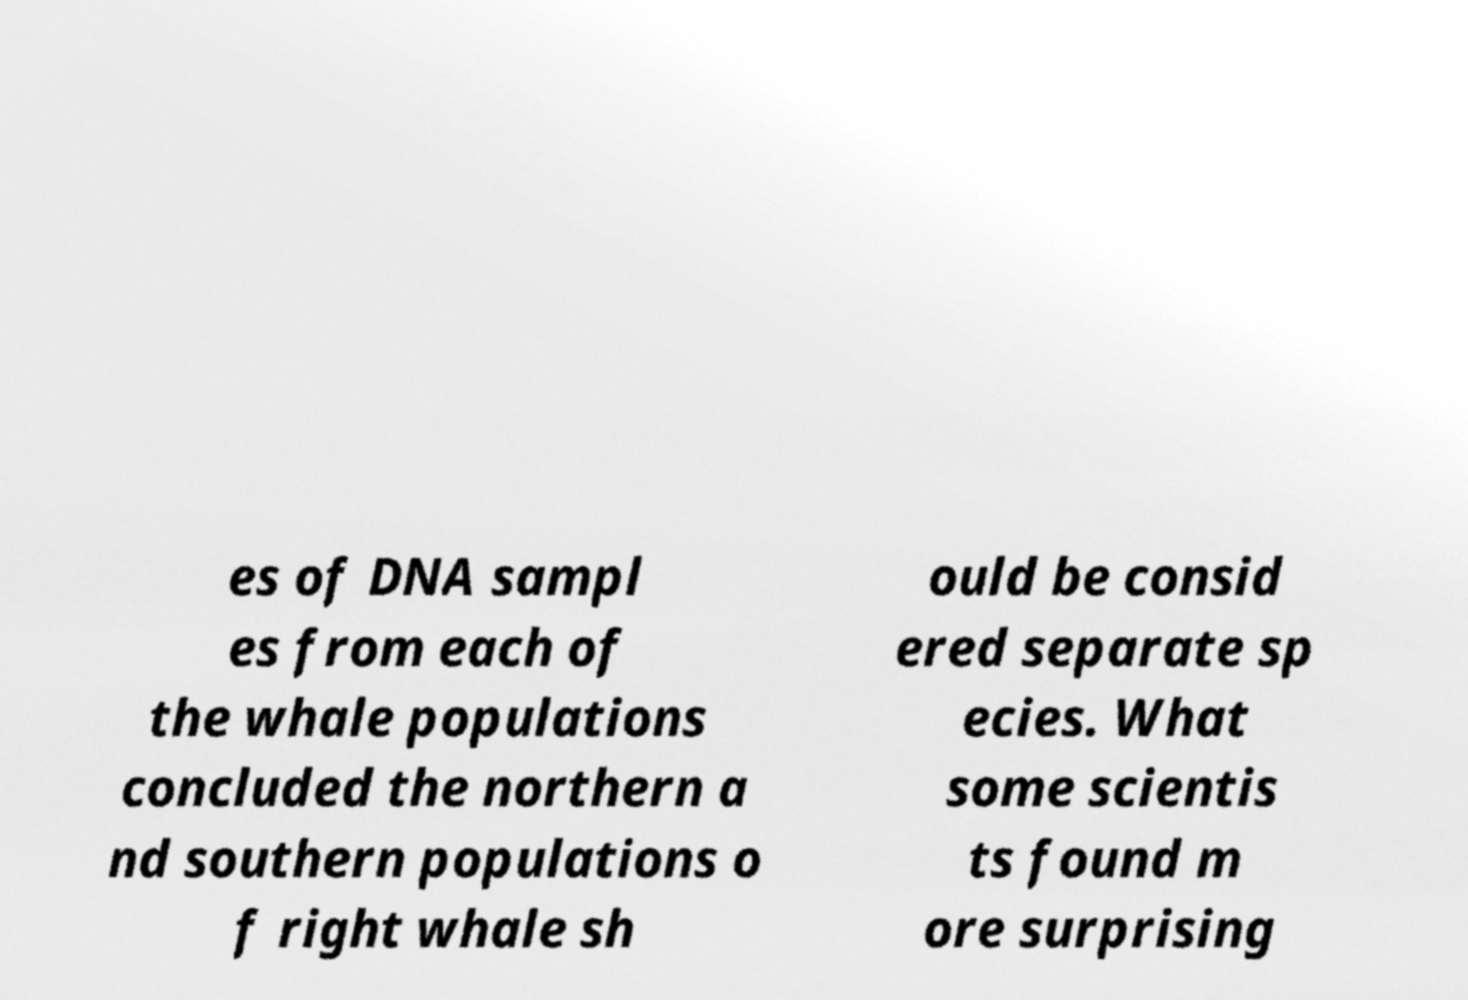Could you extract and type out the text from this image? es of DNA sampl es from each of the whale populations concluded the northern a nd southern populations o f right whale sh ould be consid ered separate sp ecies. What some scientis ts found m ore surprising 